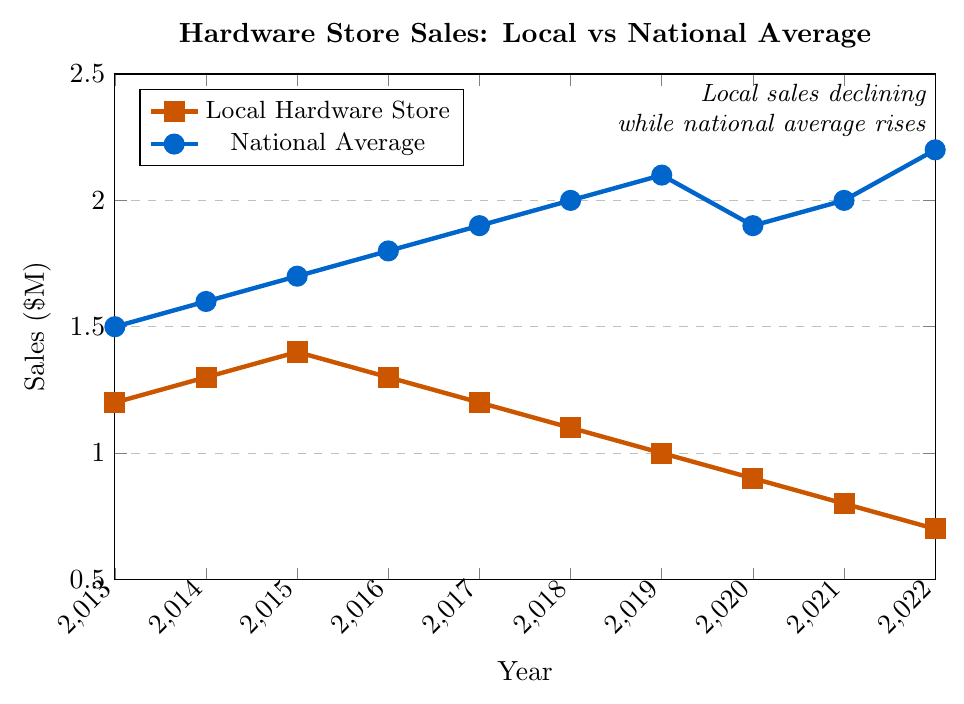What are the sales for the local hardware store and national average in 2015? To answer this, look at the coordinates for the year 2015 on both lines. For the local hardware store, the sales are $1.4M, and the national average sales are $1.7M.
Answer: Local hardware store: $1.4M, National average: $1.7M How much did the local hardware store sales decline from 2013 to 2022? To find this, subtract the sales in 2022 from the sales in 2013. The sales in 2013 were $1.2M, and in 2022, it was $0.7M. The decline is $1.2M - $0.7M.
Answer: $0.5M Over what period did the national average sales increase the most? To determine this, look for the year with the largest positive change in the national average line. The national average increased the most between 2021 ($2.0M) and 2022 ($2.2M), a rise of $0.2M.
Answer: 2021-2022 Which year showed the highest gap between local hardware store sales and the national average? To find this, calculate the differences for each year. The highest gap is in 2022, where local sales are $0.7M and national sales are $2.2M, making the gap $1.5M.
Answer: 2022 Between which years did the local hardware store experience a decline in sales every year? To answer this, observe the local hardware store sales line. From 2017 ($1.2M) to 2022 ($0.7M), sales declined each year.
Answer: 2017-2022 Is there any year where both local hardware store sales and national average sales declined? Check the slopes of both lines. Both declined from 2019 to 2020, with local sales going from $1.0M to $0.9M and national sales from $2.1M to $1.9M.
Answer: 2019-2020 What is the average national average sales over the decade? Add national average sales from 2013 to 2022 and divide by the number of years: (1.5 + 1.6 + 1.7 + 1.8 + 1.9 + 2.0 + 2.1 + 1.9 + 2.0 + 2.2) / 10. The sum is 19.7, so the average is 19.7 / 10.
Answer: $1.97M How does the trend of the local sales line compare to the national average sales line visually? Visually, the local sales line consistently declines after 2015, while the national average sales line overall shows an upward trend with a slight dip in 2020.
Answer: Local: Declines, National: Upward with a dip What was the percentage change in sales for the local hardware store from 2013 to 2022? Calculate the percentage change as (final value - initial value) / initial value. For local sales, it is (0.7 - 1.2) / 1.2 * 100%.
Answer: -41.67% Considering the data, during which year did the local hardware store sales fall below the $1.0M mark? Looking at the local hardware store sales, sales fell below $1.0M in 2019 when they reached $1.0M.
Answer: 2019 